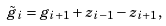<formula> <loc_0><loc_0><loc_500><loc_500>\tilde { g } _ { i } = g _ { i + 1 } + z _ { i - 1 } - z _ { i + 1 } ,</formula> 